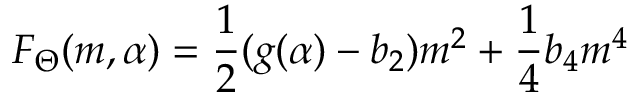<formula> <loc_0><loc_0><loc_500><loc_500>F _ { \Theta } ( m , \alpha ) = \frac { 1 } { 2 } ( g ( \alpha ) - b _ { 2 } ) m ^ { 2 } + \frac { 1 } { 4 } b _ { 4 } m ^ { 4 }</formula> 